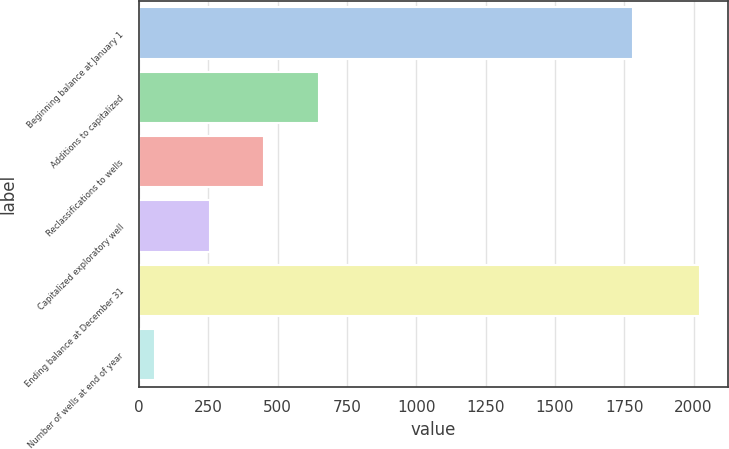Convert chart. <chart><loc_0><loc_0><loc_500><loc_500><bar_chart><fcel>Beginning balance at January 1<fcel>Additions to capitalized<fcel>Reclassifications to wells<fcel>Capitalized exploratory well<fcel>Ending balance at December 31<fcel>Number of wells at end of year<nl><fcel>1783<fcel>647.9<fcel>451.6<fcel>255.3<fcel>2022<fcel>59<nl></chart> 